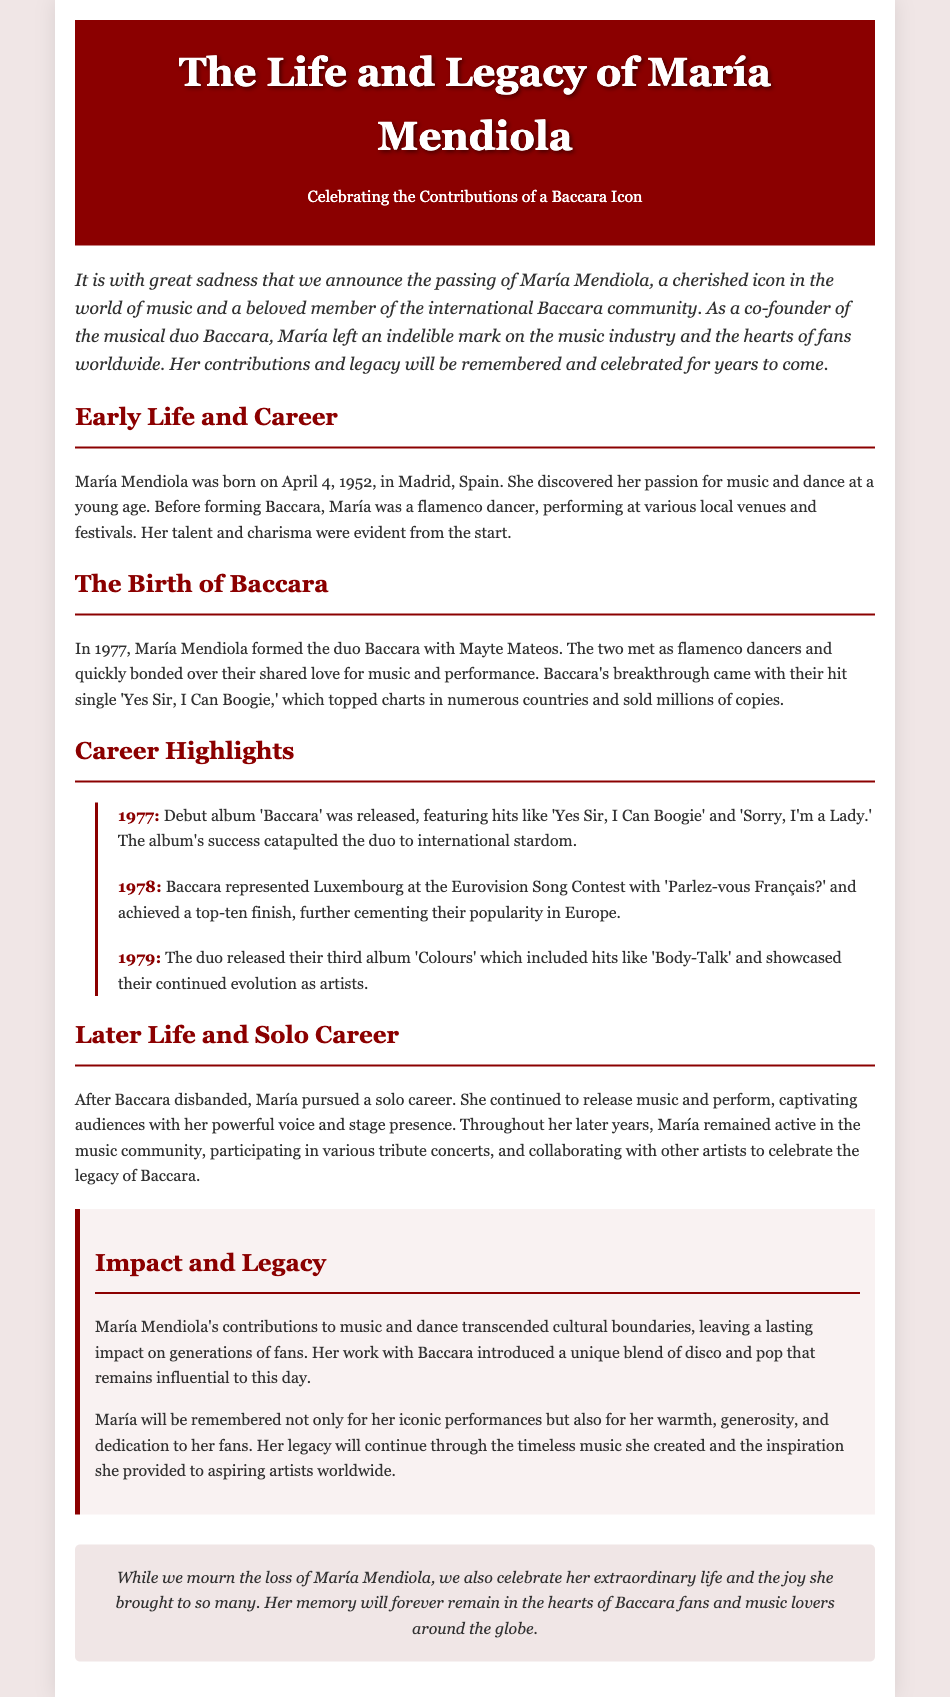what is the date of María Mendiola's birth? The document states that María Mendiola was born on April 4, 1952.
Answer: April 4, 1952 who was María's partner in forming Baccara? The document mentions that María Mendiola formed Baccara with Mayte Mateos.
Answer: Mayte Mateos what was Baccara's breakthrough hit single? According to the document, Baccara's breakthrough hit single was "Yes Sir, I Can Boogie."
Answer: Yes Sir, I Can Boogie what significant event did Baccara participate in 1978? The document states that Baccara represented Luxembourg at the Eurovision Song Contest in 1978.
Answer: Eurovision Song Contest how many albums did Baccara release before disbanding? The document mentions three albums released by Baccara before María's solo career.
Answer: Three what type of performances did María Mendiola engage in after Baccara disbanded? The document indicates that María continued to perform and participate in various tribute concerts.
Answer: Tribute concerts what genre of music is associated with Baccara's legacy? According to the document, Baccara introduced a blend of disco and pop music.
Answer: Disco and pop how is María Mendiola described in terms of her impact on fans? The document describes María as warm, generous, and dedicated to her fans.
Answer: Warm, generous, and dedicated 